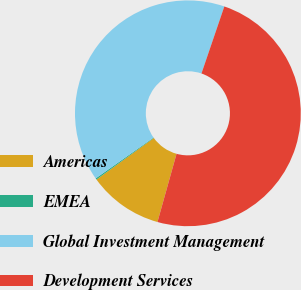Convert chart. <chart><loc_0><loc_0><loc_500><loc_500><pie_chart><fcel>Americas<fcel>EMEA<fcel>Global Investment Management<fcel>Development Services<nl><fcel>10.68%<fcel>0.19%<fcel>40.02%<fcel>49.11%<nl></chart> 